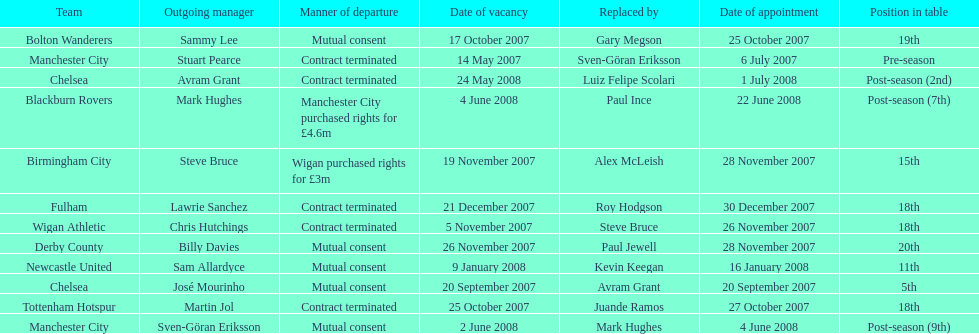Which team was the sole one to achieve a 5th place ranking? Chelsea. 